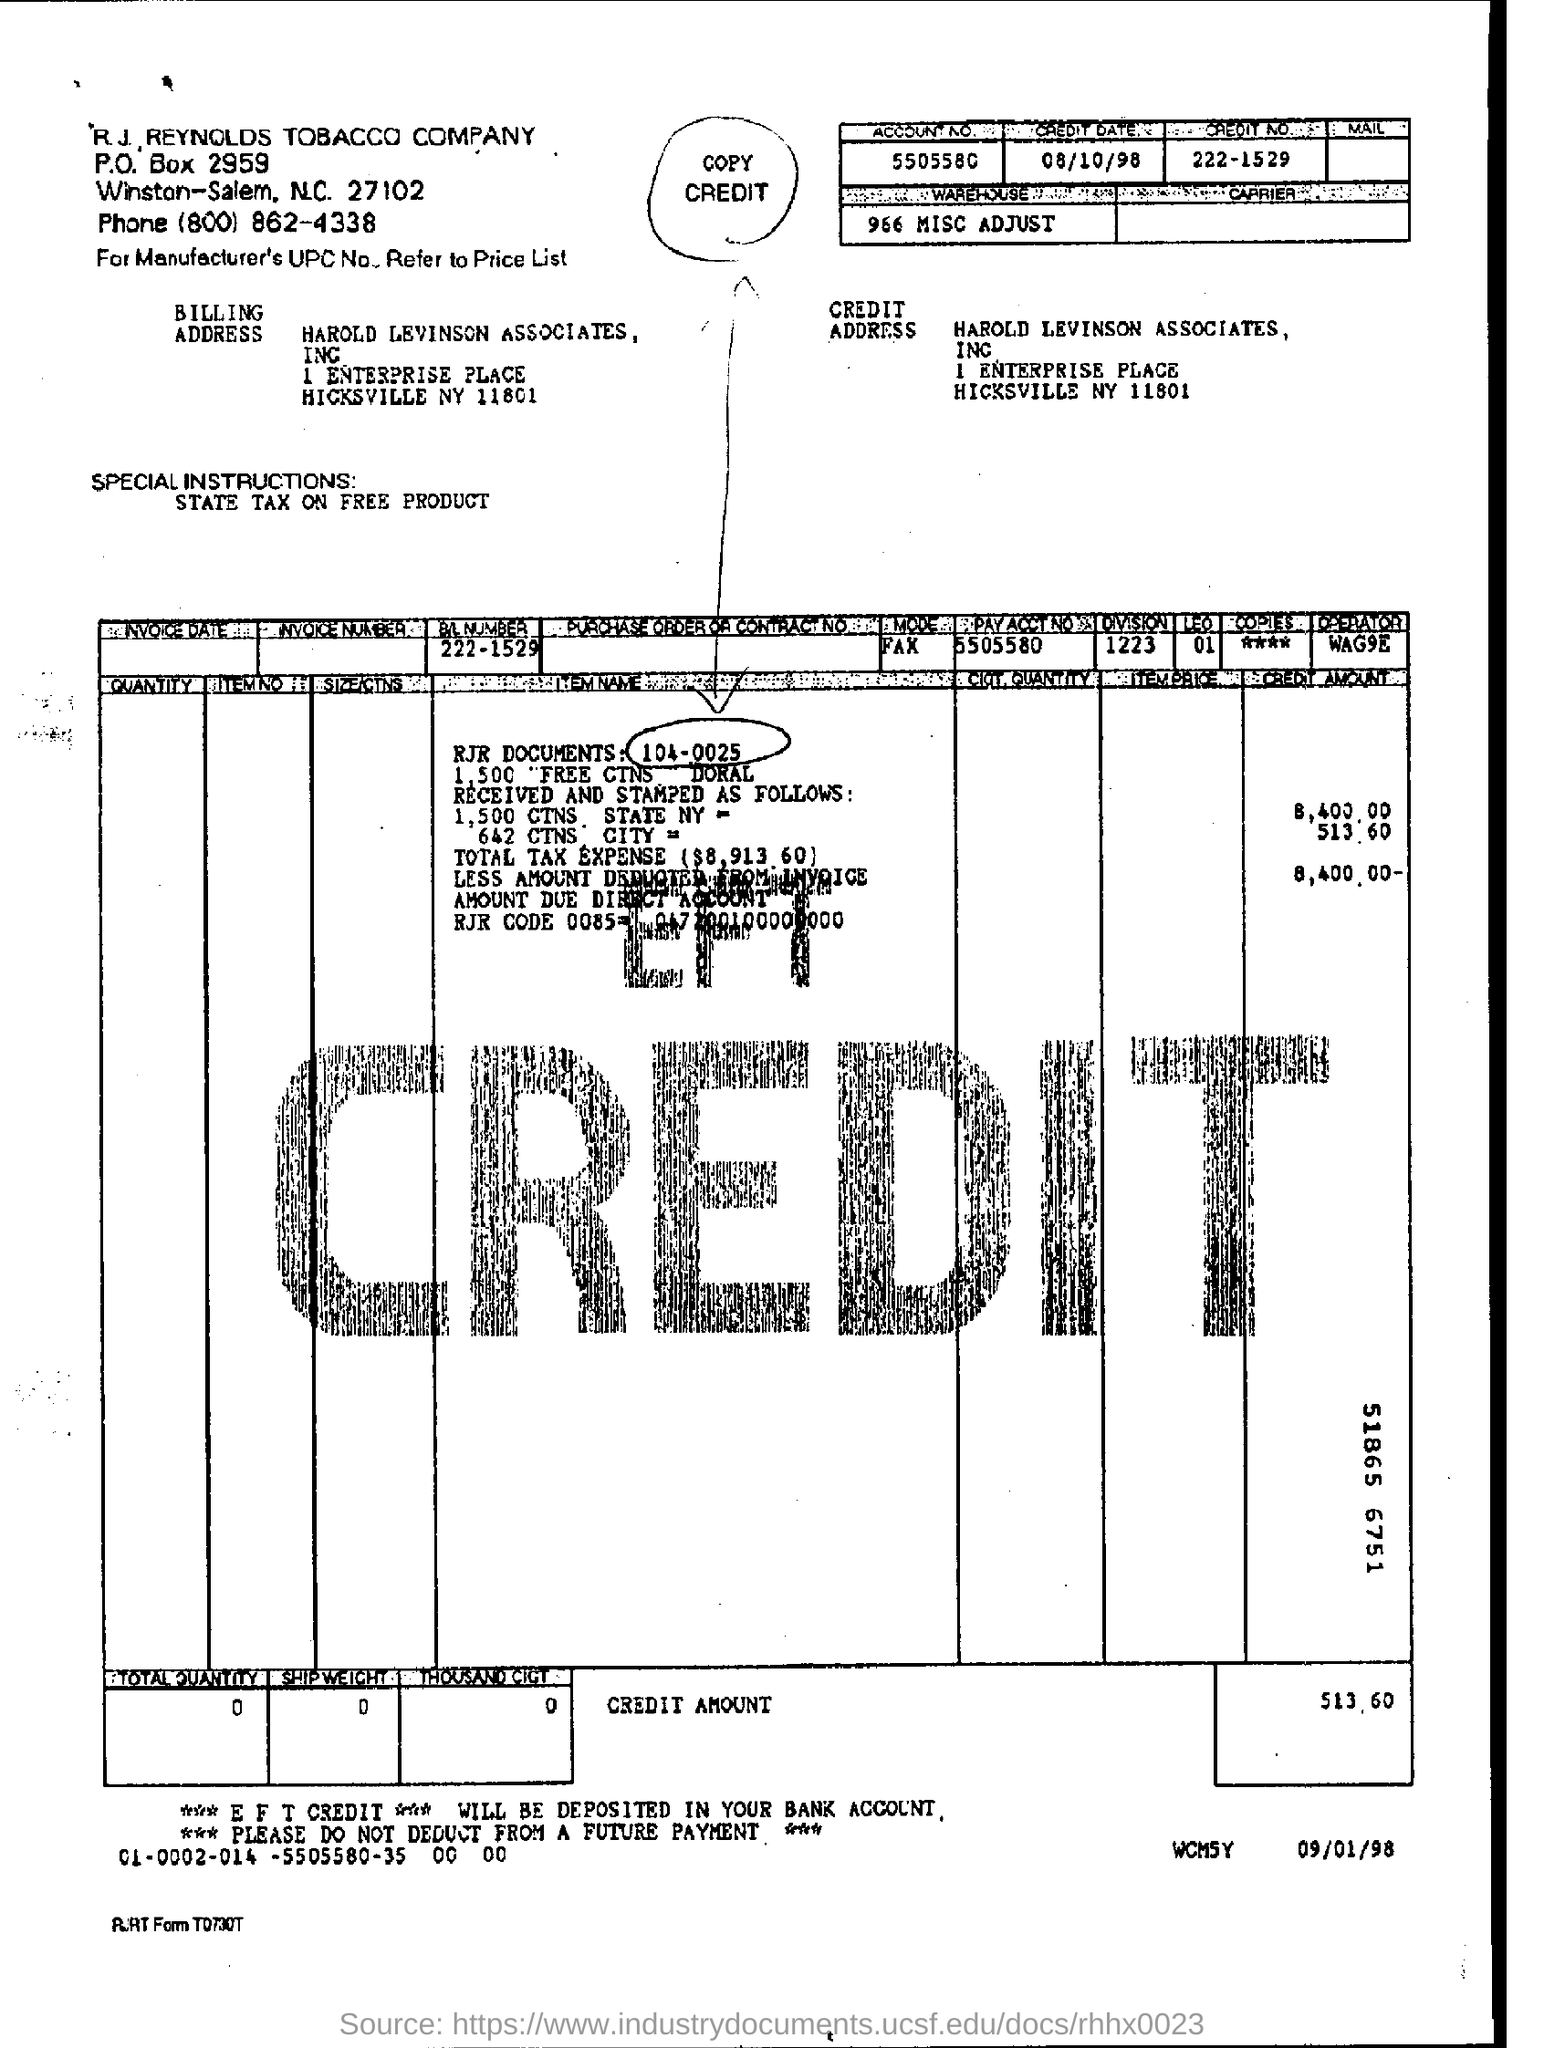What is the credit no
Your answer should be very brief. 222-1529. What is the credit date ?
Give a very brief answer. 08/10/98. 